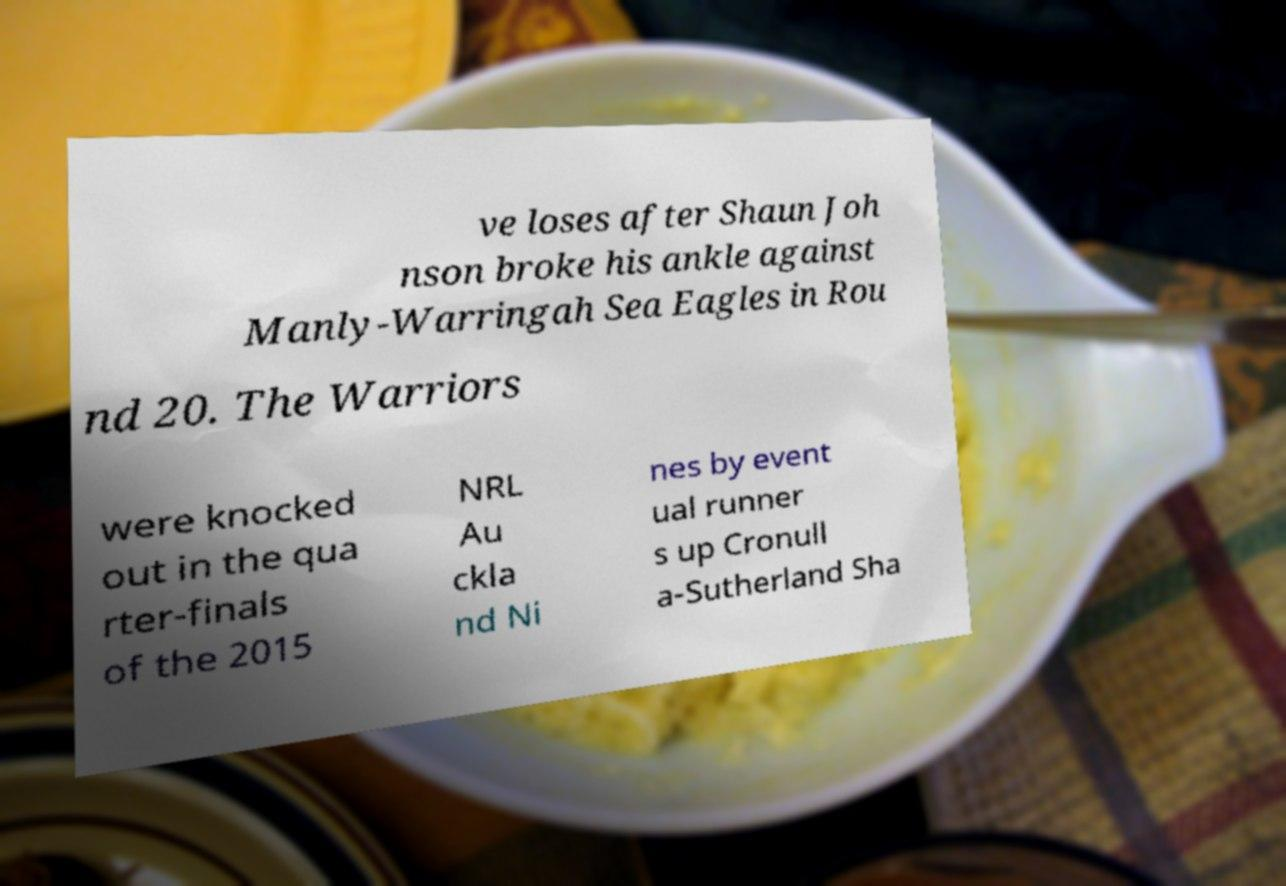Can you read and provide the text displayed in the image?This photo seems to have some interesting text. Can you extract and type it out for me? ve loses after Shaun Joh nson broke his ankle against Manly-Warringah Sea Eagles in Rou nd 20. The Warriors were knocked out in the qua rter-finals of the 2015 NRL Au ckla nd Ni nes by event ual runner s up Cronull a-Sutherland Sha 